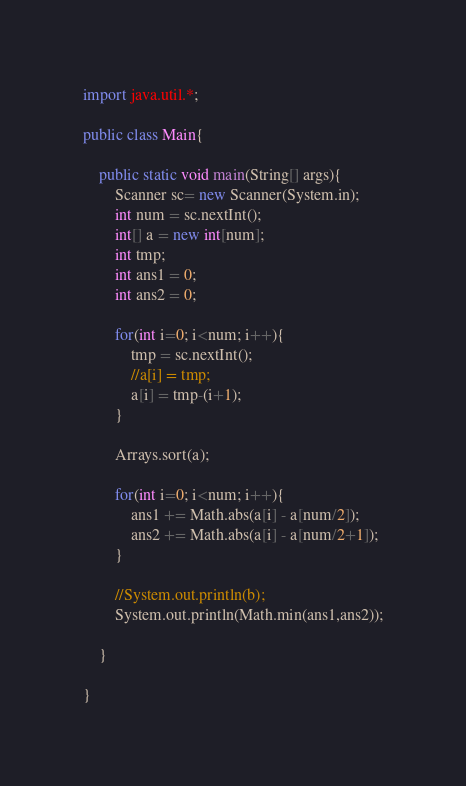Convert code to text. <code><loc_0><loc_0><loc_500><loc_500><_Java_>import java.util.*;

public class Main{
	
	public static void main(String[] args){
		Scanner sc= new Scanner(System.in);
		int num = sc.nextInt();
		int[] a = new int[num];
		int tmp;
		int ans1 = 0;
		int ans2 = 0;
		
		for(int i=0; i<num; i++){
			tmp = sc.nextInt();
			//a[i] = tmp;	
			a[i] = tmp-(i+1);	
		}

		Arrays.sort(a);
	
		for(int i=0; i<num; i++){
			ans1 += Math.abs(a[i] - a[num/2]);
			ans2 += Math.abs(a[i] - a[num/2+1]);
		}
		
		//System.out.println(b);
		System.out.println(Math.min(ans1,ans2));
		
	}

}</code> 